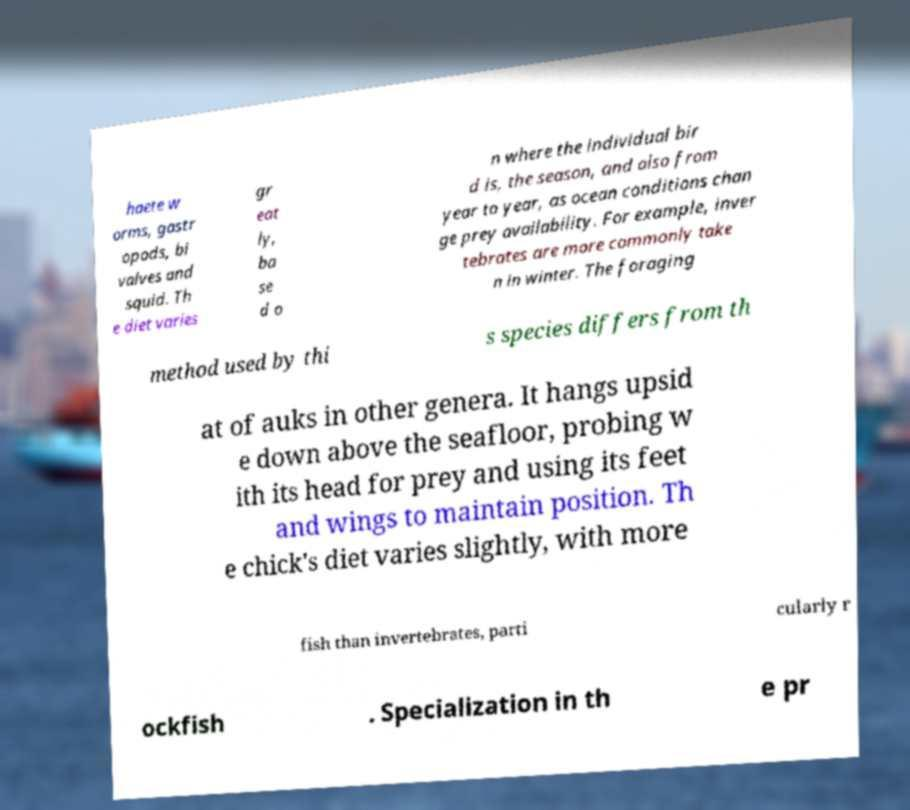Could you assist in decoding the text presented in this image and type it out clearly? haete w orms, gastr opods, bi valves and squid. Th e diet varies gr eat ly, ba se d o n where the individual bir d is, the season, and also from year to year, as ocean conditions chan ge prey availability. For example, inver tebrates are more commonly take n in winter. The foraging method used by thi s species differs from th at of auks in other genera. It hangs upsid e down above the seafloor, probing w ith its head for prey and using its feet and wings to maintain position. Th e chick's diet varies slightly, with more fish than invertebrates, parti cularly r ockfish . Specialization in th e pr 